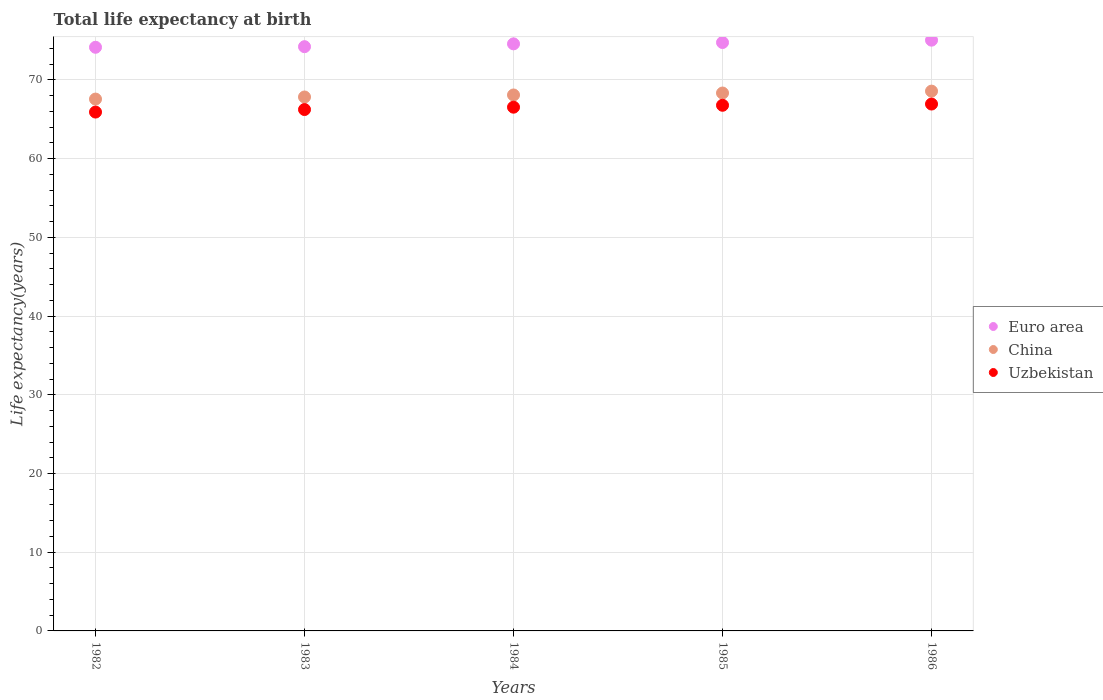What is the life expectancy at birth in in China in 1984?
Keep it short and to the point. 68.09. Across all years, what is the maximum life expectancy at birth in in Euro area?
Your response must be concise. 75.06. Across all years, what is the minimum life expectancy at birth in in Uzbekistan?
Provide a short and direct response. 65.92. In which year was the life expectancy at birth in in Euro area minimum?
Keep it short and to the point. 1982. What is the total life expectancy at birth in in Euro area in the graph?
Make the answer very short. 372.79. What is the difference between the life expectancy at birth in in China in 1984 and that in 1985?
Your answer should be very brief. -0.25. What is the difference between the life expectancy at birth in in Euro area in 1984 and the life expectancy at birth in in Uzbekistan in 1982?
Ensure brevity in your answer.  8.67. What is the average life expectancy at birth in in Euro area per year?
Offer a very short reply. 74.56. In the year 1982, what is the difference between the life expectancy at birth in in China and life expectancy at birth in in Uzbekistan?
Make the answer very short. 1.65. In how many years, is the life expectancy at birth in in China greater than 34 years?
Provide a short and direct response. 5. What is the ratio of the life expectancy at birth in in China in 1982 to that in 1986?
Make the answer very short. 0.99. Is the life expectancy at birth in in Euro area in 1982 less than that in 1984?
Offer a very short reply. Yes. What is the difference between the highest and the second highest life expectancy at birth in in Uzbekistan?
Provide a short and direct response. 0.16. What is the difference between the highest and the lowest life expectancy at birth in in Euro area?
Offer a very short reply. 0.9. In how many years, is the life expectancy at birth in in China greater than the average life expectancy at birth in in China taken over all years?
Give a very brief answer. 3. Is it the case that in every year, the sum of the life expectancy at birth in in Euro area and life expectancy at birth in in China  is greater than the life expectancy at birth in in Uzbekistan?
Give a very brief answer. Yes. How many dotlines are there?
Offer a very short reply. 3. Are the values on the major ticks of Y-axis written in scientific E-notation?
Keep it short and to the point. No. Does the graph contain any zero values?
Your response must be concise. No. Does the graph contain grids?
Your response must be concise. Yes. How are the legend labels stacked?
Ensure brevity in your answer.  Vertical. What is the title of the graph?
Your answer should be very brief. Total life expectancy at birth. What is the label or title of the X-axis?
Offer a terse response. Years. What is the label or title of the Y-axis?
Your answer should be compact. Life expectancy(years). What is the Life expectancy(years) of Euro area in 1982?
Keep it short and to the point. 74.15. What is the Life expectancy(years) in China in 1982?
Your answer should be very brief. 67.57. What is the Life expectancy(years) in Uzbekistan in 1982?
Provide a short and direct response. 65.92. What is the Life expectancy(years) in Euro area in 1983?
Offer a terse response. 74.23. What is the Life expectancy(years) of China in 1983?
Give a very brief answer. 67.84. What is the Life expectancy(years) of Uzbekistan in 1983?
Your answer should be compact. 66.24. What is the Life expectancy(years) of Euro area in 1984?
Your answer should be very brief. 74.59. What is the Life expectancy(years) of China in 1984?
Provide a succinct answer. 68.09. What is the Life expectancy(years) of Uzbekistan in 1984?
Keep it short and to the point. 66.54. What is the Life expectancy(years) of Euro area in 1985?
Provide a short and direct response. 74.76. What is the Life expectancy(years) of China in 1985?
Your answer should be very brief. 68.34. What is the Life expectancy(years) of Uzbekistan in 1985?
Ensure brevity in your answer.  66.79. What is the Life expectancy(years) in Euro area in 1986?
Offer a very short reply. 75.06. What is the Life expectancy(years) of China in 1986?
Ensure brevity in your answer.  68.58. What is the Life expectancy(years) in Uzbekistan in 1986?
Make the answer very short. 66.94. Across all years, what is the maximum Life expectancy(years) in Euro area?
Offer a terse response. 75.06. Across all years, what is the maximum Life expectancy(years) of China?
Ensure brevity in your answer.  68.58. Across all years, what is the maximum Life expectancy(years) in Uzbekistan?
Provide a short and direct response. 66.94. Across all years, what is the minimum Life expectancy(years) in Euro area?
Provide a succinct answer. 74.15. Across all years, what is the minimum Life expectancy(years) of China?
Offer a terse response. 67.57. Across all years, what is the minimum Life expectancy(years) of Uzbekistan?
Make the answer very short. 65.92. What is the total Life expectancy(years) in Euro area in the graph?
Your response must be concise. 372.79. What is the total Life expectancy(years) in China in the graph?
Ensure brevity in your answer.  340.43. What is the total Life expectancy(years) of Uzbekistan in the graph?
Your response must be concise. 332.44. What is the difference between the Life expectancy(years) of Euro area in 1982 and that in 1983?
Your response must be concise. -0.08. What is the difference between the Life expectancy(years) in China in 1982 and that in 1983?
Your answer should be very brief. -0.26. What is the difference between the Life expectancy(years) of Uzbekistan in 1982 and that in 1983?
Provide a succinct answer. -0.32. What is the difference between the Life expectancy(years) in Euro area in 1982 and that in 1984?
Your response must be concise. -0.43. What is the difference between the Life expectancy(years) in China in 1982 and that in 1984?
Your response must be concise. -0.52. What is the difference between the Life expectancy(years) of Uzbekistan in 1982 and that in 1984?
Your response must be concise. -0.62. What is the difference between the Life expectancy(years) of Euro area in 1982 and that in 1985?
Give a very brief answer. -0.6. What is the difference between the Life expectancy(years) in China in 1982 and that in 1985?
Provide a succinct answer. -0.77. What is the difference between the Life expectancy(years) of Uzbekistan in 1982 and that in 1985?
Offer a very short reply. -0.86. What is the difference between the Life expectancy(years) in Euro area in 1982 and that in 1986?
Give a very brief answer. -0.9. What is the difference between the Life expectancy(years) in China in 1982 and that in 1986?
Your response must be concise. -1.01. What is the difference between the Life expectancy(years) of Uzbekistan in 1982 and that in 1986?
Your answer should be very brief. -1.02. What is the difference between the Life expectancy(years) of Euro area in 1983 and that in 1984?
Your response must be concise. -0.36. What is the difference between the Life expectancy(years) of China in 1983 and that in 1984?
Make the answer very short. -0.26. What is the difference between the Life expectancy(years) of Uzbekistan in 1983 and that in 1984?
Give a very brief answer. -0.3. What is the difference between the Life expectancy(years) of Euro area in 1983 and that in 1985?
Give a very brief answer. -0.53. What is the difference between the Life expectancy(years) of China in 1983 and that in 1985?
Keep it short and to the point. -0.5. What is the difference between the Life expectancy(years) in Uzbekistan in 1983 and that in 1985?
Provide a succinct answer. -0.54. What is the difference between the Life expectancy(years) of Euro area in 1983 and that in 1986?
Offer a very short reply. -0.83. What is the difference between the Life expectancy(years) of China in 1983 and that in 1986?
Provide a succinct answer. -0.75. What is the difference between the Life expectancy(years) in Uzbekistan in 1983 and that in 1986?
Your response must be concise. -0.7. What is the difference between the Life expectancy(years) of Euro area in 1984 and that in 1985?
Offer a terse response. -0.17. What is the difference between the Life expectancy(years) in China in 1984 and that in 1985?
Provide a succinct answer. -0.25. What is the difference between the Life expectancy(years) in Uzbekistan in 1984 and that in 1985?
Ensure brevity in your answer.  -0.24. What is the difference between the Life expectancy(years) in Euro area in 1984 and that in 1986?
Keep it short and to the point. -0.47. What is the difference between the Life expectancy(years) of China in 1984 and that in 1986?
Provide a succinct answer. -0.49. What is the difference between the Life expectancy(years) in Uzbekistan in 1984 and that in 1986?
Your answer should be very brief. -0.4. What is the difference between the Life expectancy(years) of Euro area in 1985 and that in 1986?
Provide a succinct answer. -0.3. What is the difference between the Life expectancy(years) in China in 1985 and that in 1986?
Provide a short and direct response. -0.24. What is the difference between the Life expectancy(years) of Uzbekistan in 1985 and that in 1986?
Keep it short and to the point. -0.16. What is the difference between the Life expectancy(years) in Euro area in 1982 and the Life expectancy(years) in China in 1983?
Give a very brief answer. 6.32. What is the difference between the Life expectancy(years) in Euro area in 1982 and the Life expectancy(years) in Uzbekistan in 1983?
Your response must be concise. 7.91. What is the difference between the Life expectancy(years) of China in 1982 and the Life expectancy(years) of Uzbekistan in 1983?
Provide a succinct answer. 1.33. What is the difference between the Life expectancy(years) of Euro area in 1982 and the Life expectancy(years) of China in 1984?
Make the answer very short. 6.06. What is the difference between the Life expectancy(years) in Euro area in 1982 and the Life expectancy(years) in Uzbekistan in 1984?
Your answer should be very brief. 7.61. What is the difference between the Life expectancy(years) of China in 1982 and the Life expectancy(years) of Uzbekistan in 1984?
Provide a short and direct response. 1.03. What is the difference between the Life expectancy(years) in Euro area in 1982 and the Life expectancy(years) in China in 1985?
Your response must be concise. 5.81. What is the difference between the Life expectancy(years) in Euro area in 1982 and the Life expectancy(years) in Uzbekistan in 1985?
Offer a terse response. 7.37. What is the difference between the Life expectancy(years) of China in 1982 and the Life expectancy(years) of Uzbekistan in 1985?
Provide a succinct answer. 0.79. What is the difference between the Life expectancy(years) in Euro area in 1982 and the Life expectancy(years) in China in 1986?
Your answer should be very brief. 5.57. What is the difference between the Life expectancy(years) of Euro area in 1982 and the Life expectancy(years) of Uzbekistan in 1986?
Provide a short and direct response. 7.21. What is the difference between the Life expectancy(years) in China in 1982 and the Life expectancy(years) in Uzbekistan in 1986?
Keep it short and to the point. 0.63. What is the difference between the Life expectancy(years) in Euro area in 1983 and the Life expectancy(years) in China in 1984?
Provide a succinct answer. 6.14. What is the difference between the Life expectancy(years) in Euro area in 1983 and the Life expectancy(years) in Uzbekistan in 1984?
Keep it short and to the point. 7.69. What is the difference between the Life expectancy(years) of China in 1983 and the Life expectancy(years) of Uzbekistan in 1984?
Provide a succinct answer. 1.29. What is the difference between the Life expectancy(years) in Euro area in 1983 and the Life expectancy(years) in China in 1985?
Ensure brevity in your answer.  5.89. What is the difference between the Life expectancy(years) in Euro area in 1983 and the Life expectancy(years) in Uzbekistan in 1985?
Give a very brief answer. 7.44. What is the difference between the Life expectancy(years) of China in 1983 and the Life expectancy(years) of Uzbekistan in 1985?
Provide a short and direct response. 1.05. What is the difference between the Life expectancy(years) in Euro area in 1983 and the Life expectancy(years) in China in 1986?
Keep it short and to the point. 5.65. What is the difference between the Life expectancy(years) of Euro area in 1983 and the Life expectancy(years) of Uzbekistan in 1986?
Your response must be concise. 7.29. What is the difference between the Life expectancy(years) of China in 1983 and the Life expectancy(years) of Uzbekistan in 1986?
Your response must be concise. 0.89. What is the difference between the Life expectancy(years) of Euro area in 1984 and the Life expectancy(years) of China in 1985?
Provide a succinct answer. 6.25. What is the difference between the Life expectancy(years) in Euro area in 1984 and the Life expectancy(years) in Uzbekistan in 1985?
Provide a succinct answer. 7.8. What is the difference between the Life expectancy(years) in China in 1984 and the Life expectancy(years) in Uzbekistan in 1985?
Keep it short and to the point. 1.31. What is the difference between the Life expectancy(years) in Euro area in 1984 and the Life expectancy(years) in China in 1986?
Provide a succinct answer. 6.01. What is the difference between the Life expectancy(years) of Euro area in 1984 and the Life expectancy(years) of Uzbekistan in 1986?
Provide a succinct answer. 7.65. What is the difference between the Life expectancy(years) of China in 1984 and the Life expectancy(years) of Uzbekistan in 1986?
Provide a short and direct response. 1.15. What is the difference between the Life expectancy(years) in Euro area in 1985 and the Life expectancy(years) in China in 1986?
Your answer should be compact. 6.18. What is the difference between the Life expectancy(years) in Euro area in 1985 and the Life expectancy(years) in Uzbekistan in 1986?
Your answer should be compact. 7.82. What is the difference between the Life expectancy(years) in China in 1985 and the Life expectancy(years) in Uzbekistan in 1986?
Make the answer very short. 1.4. What is the average Life expectancy(years) of Euro area per year?
Ensure brevity in your answer.  74.56. What is the average Life expectancy(years) of China per year?
Your response must be concise. 68.08. What is the average Life expectancy(years) in Uzbekistan per year?
Keep it short and to the point. 66.49. In the year 1982, what is the difference between the Life expectancy(years) in Euro area and Life expectancy(years) in China?
Give a very brief answer. 6.58. In the year 1982, what is the difference between the Life expectancy(years) of Euro area and Life expectancy(years) of Uzbekistan?
Your answer should be very brief. 8.23. In the year 1982, what is the difference between the Life expectancy(years) of China and Life expectancy(years) of Uzbekistan?
Make the answer very short. 1.65. In the year 1983, what is the difference between the Life expectancy(years) of Euro area and Life expectancy(years) of China?
Your answer should be compact. 6.39. In the year 1983, what is the difference between the Life expectancy(years) in Euro area and Life expectancy(years) in Uzbekistan?
Keep it short and to the point. 7.99. In the year 1983, what is the difference between the Life expectancy(years) in China and Life expectancy(years) in Uzbekistan?
Your answer should be compact. 1.59. In the year 1984, what is the difference between the Life expectancy(years) of Euro area and Life expectancy(years) of China?
Your response must be concise. 6.5. In the year 1984, what is the difference between the Life expectancy(years) in Euro area and Life expectancy(years) in Uzbekistan?
Offer a terse response. 8.05. In the year 1984, what is the difference between the Life expectancy(years) in China and Life expectancy(years) in Uzbekistan?
Offer a very short reply. 1.55. In the year 1985, what is the difference between the Life expectancy(years) in Euro area and Life expectancy(years) in China?
Offer a terse response. 6.42. In the year 1985, what is the difference between the Life expectancy(years) of Euro area and Life expectancy(years) of Uzbekistan?
Keep it short and to the point. 7.97. In the year 1985, what is the difference between the Life expectancy(years) of China and Life expectancy(years) of Uzbekistan?
Keep it short and to the point. 1.56. In the year 1986, what is the difference between the Life expectancy(years) in Euro area and Life expectancy(years) in China?
Offer a very short reply. 6.47. In the year 1986, what is the difference between the Life expectancy(years) of Euro area and Life expectancy(years) of Uzbekistan?
Offer a terse response. 8.11. In the year 1986, what is the difference between the Life expectancy(years) of China and Life expectancy(years) of Uzbekistan?
Keep it short and to the point. 1.64. What is the ratio of the Life expectancy(years) in China in 1982 to that in 1983?
Offer a very short reply. 1. What is the ratio of the Life expectancy(years) of Euro area in 1982 to that in 1984?
Ensure brevity in your answer.  0.99. What is the ratio of the Life expectancy(years) in China in 1982 to that in 1984?
Your answer should be compact. 0.99. What is the ratio of the Life expectancy(years) in Uzbekistan in 1982 to that in 1984?
Keep it short and to the point. 0.99. What is the ratio of the Life expectancy(years) of China in 1982 to that in 1985?
Keep it short and to the point. 0.99. What is the ratio of the Life expectancy(years) in Uzbekistan in 1982 to that in 1985?
Ensure brevity in your answer.  0.99. What is the ratio of the Life expectancy(years) in Euro area in 1982 to that in 1986?
Provide a succinct answer. 0.99. What is the ratio of the Life expectancy(years) in Euro area in 1983 to that in 1984?
Your answer should be compact. 1. What is the ratio of the Life expectancy(years) of Euro area in 1983 to that in 1985?
Your response must be concise. 0.99. What is the ratio of the Life expectancy(years) of China in 1983 to that in 1985?
Offer a very short reply. 0.99. What is the ratio of the Life expectancy(years) of Uzbekistan in 1983 to that in 1986?
Offer a very short reply. 0.99. What is the ratio of the Life expectancy(years) of China in 1984 to that in 1985?
Offer a very short reply. 1. What is the ratio of the Life expectancy(years) in Uzbekistan in 1984 to that in 1985?
Provide a succinct answer. 1. What is the ratio of the Life expectancy(years) in Euro area in 1984 to that in 1986?
Keep it short and to the point. 0.99. What is the ratio of the Life expectancy(years) of China in 1984 to that in 1986?
Offer a terse response. 0.99. What is the ratio of the Life expectancy(years) of Uzbekistan in 1984 to that in 1986?
Offer a terse response. 0.99. What is the ratio of the Life expectancy(years) of Euro area in 1985 to that in 1986?
Your answer should be compact. 1. What is the ratio of the Life expectancy(years) in China in 1985 to that in 1986?
Ensure brevity in your answer.  1. What is the difference between the highest and the second highest Life expectancy(years) of Euro area?
Provide a short and direct response. 0.3. What is the difference between the highest and the second highest Life expectancy(years) of China?
Give a very brief answer. 0.24. What is the difference between the highest and the second highest Life expectancy(years) in Uzbekistan?
Your answer should be very brief. 0.16. What is the difference between the highest and the lowest Life expectancy(years) of Euro area?
Your response must be concise. 0.9. What is the difference between the highest and the lowest Life expectancy(years) in China?
Your answer should be compact. 1.01. What is the difference between the highest and the lowest Life expectancy(years) in Uzbekistan?
Ensure brevity in your answer.  1.02. 